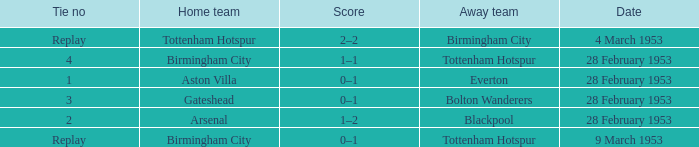Which Home team has an Away team of everton? Aston Villa. 